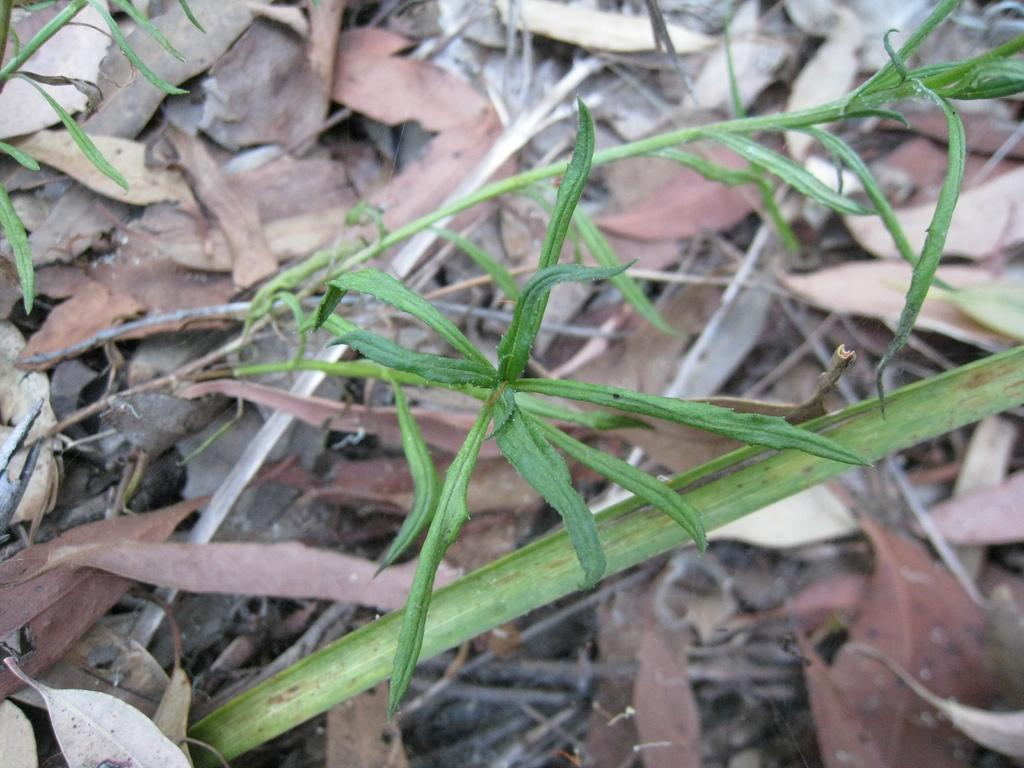What is present in the image? There is a plant in the image. Can you describe the plant's appearance? The plant has leaves at the bottom. What type of collar is the plant wearing in the image? There is no collar present in the image, as plants do not wear collars. 